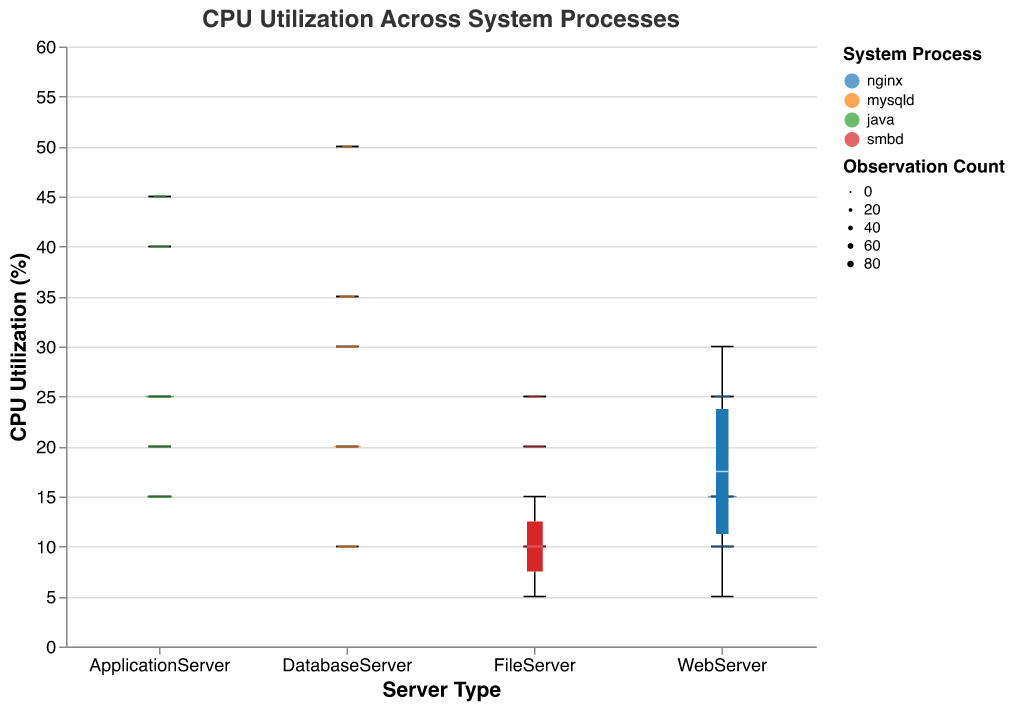What is the title of the plot? The title of the plot is displayed at the top of the figure. It reads "CPU Utilization Across System Processes".
Answer: CPU Utilization Across System Processes What are the different server types represented in the plot? The different server types can be identified from the x-axis labels. They are WebServer, DatabaseServer, ApplicationServer, and FileServer.
Answer: WebServer, DatabaseServer, ApplicationServer, FileServer Which system process has the highest maximum CPU utilization and in which server type is it observed? The highest maximum CPU utilization can be identified by looking at the topmost points of the box plots for each server type. It is seen for the 'mysqld' process in the DatabaseServer, reaching a CPU utilization of 50%.
Answer: mysqld in DatabaseServer What is the observation count for the WebServer's 'nginx' process at 15% CPU utilization? The size of the boxplots is determined by the observation count, which is also indicated in the legend. For 'nginx' at 15% CPU utilization, the observation count is marked as 80.
Answer: 80 Which server type shows the most variability in CPU utilization? Variability can be assessed by looking at the height and range of the boxplots for each server type. The DatabaseServer has the largest variability, evident by the wide range of the 'mysqld' process.
Answer: DatabaseServer What is the median CPU utilization for the ApplicationServer's 'java' process? The median is represented by the line inside the boxplot. For 'java' in ApplicationServer, the median CPU utilization is approximately 25%.
Answer: 25% Comparing the 'nginx' process in the WebServer and the 'smbd' process in the FileServer, which has a lower median CPU utilization? The median CPU utilization for 'nginx' in WebServer is lower than 'smbd' in FileServer. For 'nginx', it is around 15%, while for 'smbd' it is about 15-20%.
Answer: nginx in WebServer How does the median CPU utilization of 'mysqld' in DatabaseServer compare with 'java' in ApplicationServer? The median CPU utilization of 'mysqld' in DatabaseServer (approximately 20%) is lower than that of 'java' in ApplicationServer (approximately 25%).
Answer: Lower What is the range of CPU utilization for the FileServer's 'smbd' process? The range of CPU utilization can be determined by the minimum and maximum values for 'smbd' in the FileServer. It ranges from 5% to 25%.
Answer: 5% to 25% What is the smallest observation count for any process, and for which process and server type does it occur? The smallest observation count can be observed from the size of the boxplots. The 'mysqld' process in the DatabaseServer has the smallest observation count of 20 at 50% CPU utilization.
Answer: 20, mysqld in DatabaseServer 